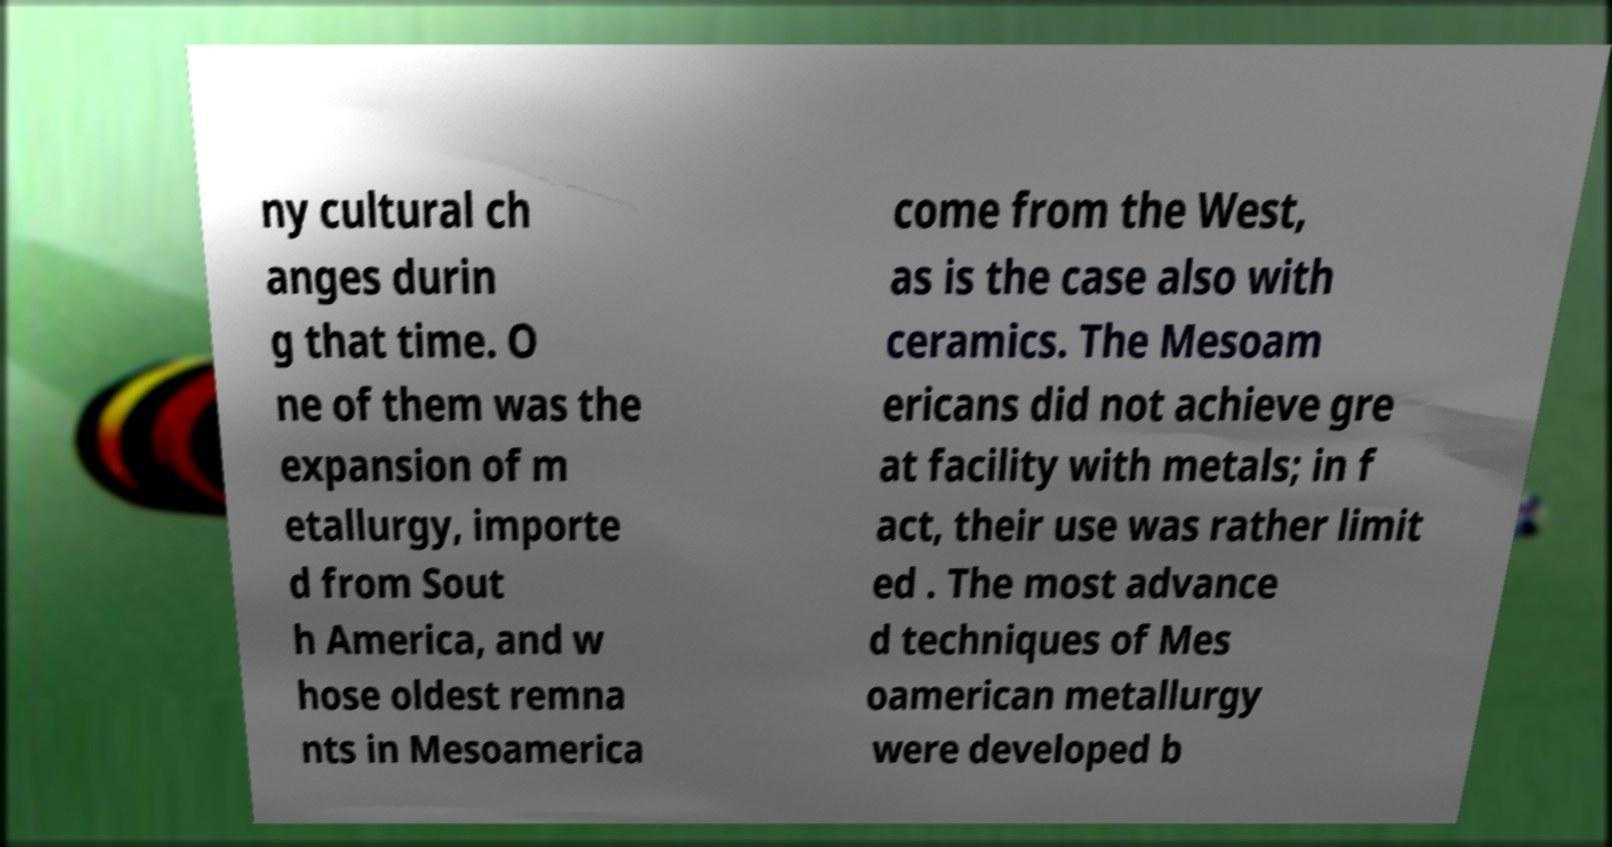Please identify and transcribe the text found in this image. ny cultural ch anges durin g that time. O ne of them was the expansion of m etallurgy, importe d from Sout h America, and w hose oldest remna nts in Mesoamerica come from the West, as is the case also with ceramics. The Mesoam ericans did not achieve gre at facility with metals; in f act, their use was rather limit ed . The most advance d techniques of Mes oamerican metallurgy were developed b 